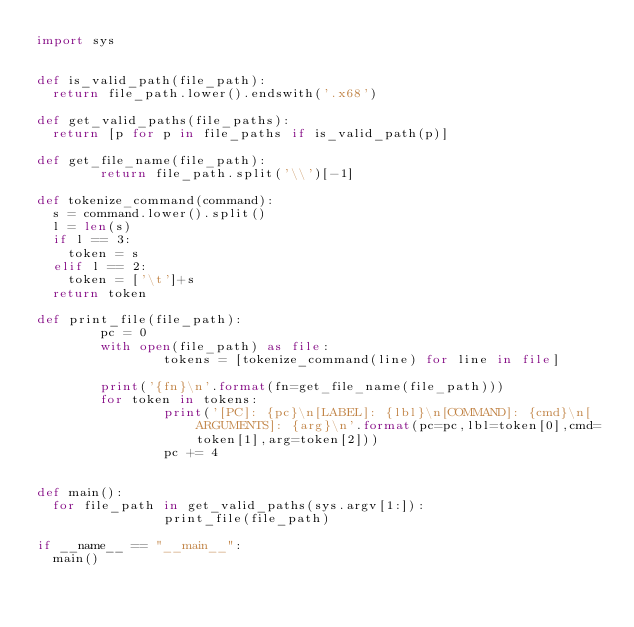<code> <loc_0><loc_0><loc_500><loc_500><_Python_>import sys


def is_valid_path(file_path):
	return file_path.lower().endswith('.x68')

def get_valid_paths(file_paths):
	return [p for p in file_paths if is_valid_path(p)]

def get_file_name(file_path):
        return file_path.split('\\')[-1]

def tokenize_command(command):
	s = command.lower().split()
	l = len(s)
	if l == 3:
		token = s
	elif l == 2:
		token = ['\t']+s
	return token

def print_file(file_path):
        pc = 0
        with open(file_path) as file:
                tokens = [tokenize_command(line) for line in file]

        print('{fn}\n'.format(fn=get_file_name(file_path)))
        for token in tokens:
                print('[PC]: {pc}\n[LABEL]: {lbl}\n[COMMAND]: {cmd}\n[ARGUMENTS]: {arg}\n'.format(pc=pc,lbl=token[0],cmd=token[1],arg=token[2]))
                pc += 4
                
        
def main():
	for file_path in get_valid_paths(sys.argv[1:]):
                print_file(file_path)

if __name__ == "__main__":
	main()
</code> 